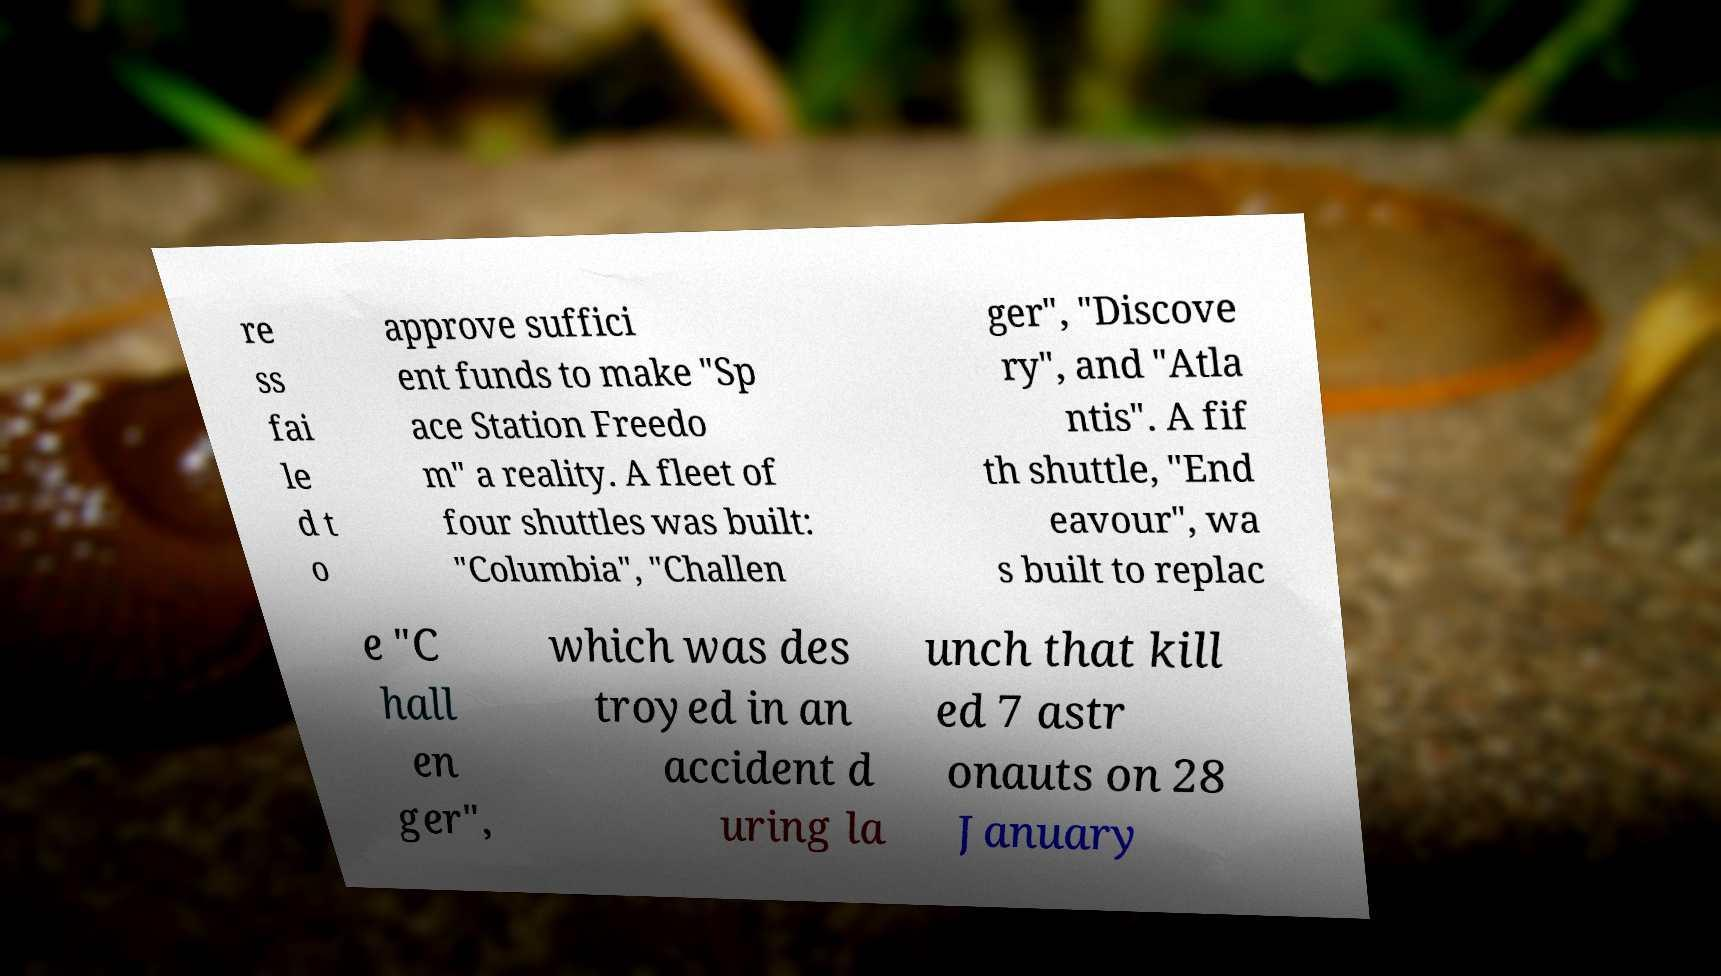There's text embedded in this image that I need extracted. Can you transcribe it verbatim? re ss fai le d t o approve suffici ent funds to make "Sp ace Station Freedo m" a reality. A fleet of four shuttles was built: "Columbia", "Challen ger", "Discove ry", and "Atla ntis". A fif th shuttle, "End eavour", wa s built to replac e "C hall en ger", which was des troyed in an accident d uring la unch that kill ed 7 astr onauts on 28 January 